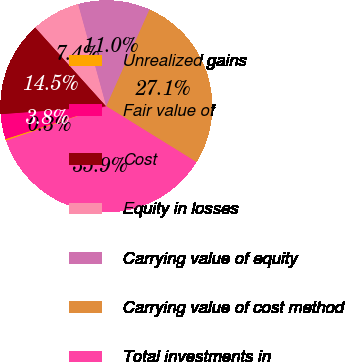Convert chart to OTSL. <chart><loc_0><loc_0><loc_500><loc_500><pie_chart><fcel>Unrealized gains<fcel>Fair value of<fcel>Cost<fcel>Equity in losses<fcel>Carrying value of equity<fcel>Carrying value of cost method<fcel>Total investments in<nl><fcel>0.25%<fcel>3.82%<fcel>14.52%<fcel>7.39%<fcel>10.96%<fcel>27.13%<fcel>35.92%<nl></chart> 